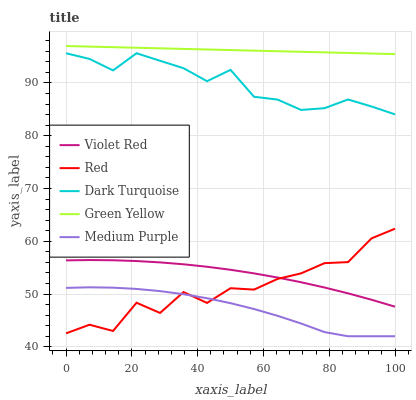Does Dark Turquoise have the minimum area under the curve?
Answer yes or no. No. Does Dark Turquoise have the maximum area under the curve?
Answer yes or no. No. Is Dark Turquoise the smoothest?
Answer yes or no. No. Is Dark Turquoise the roughest?
Answer yes or no. No. Does Dark Turquoise have the lowest value?
Answer yes or no. No. Does Dark Turquoise have the highest value?
Answer yes or no. No. Is Medium Purple less than Dark Turquoise?
Answer yes or no. Yes. Is Green Yellow greater than Medium Purple?
Answer yes or no. Yes. Does Medium Purple intersect Dark Turquoise?
Answer yes or no. No. 